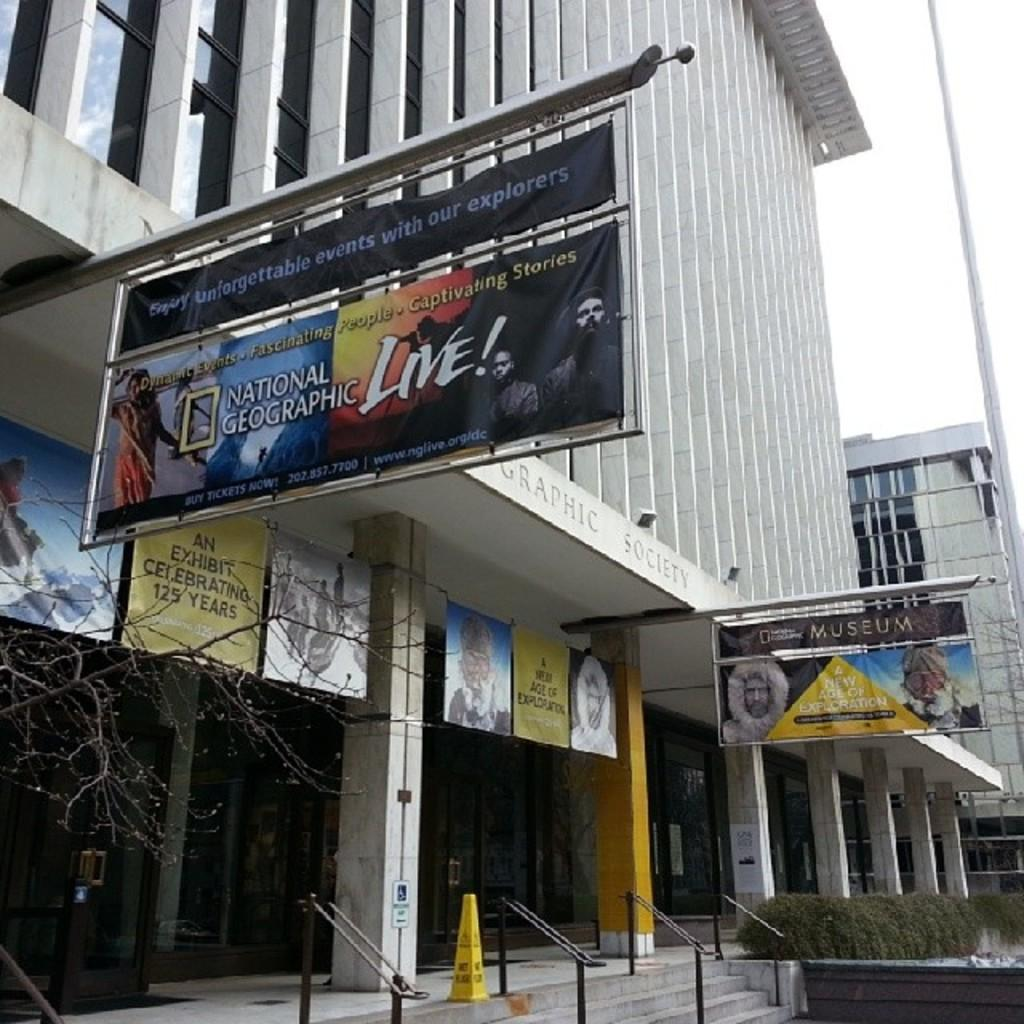<image>
Describe the image concisely. A horizontal sign for National Geographic hangs from a building. 